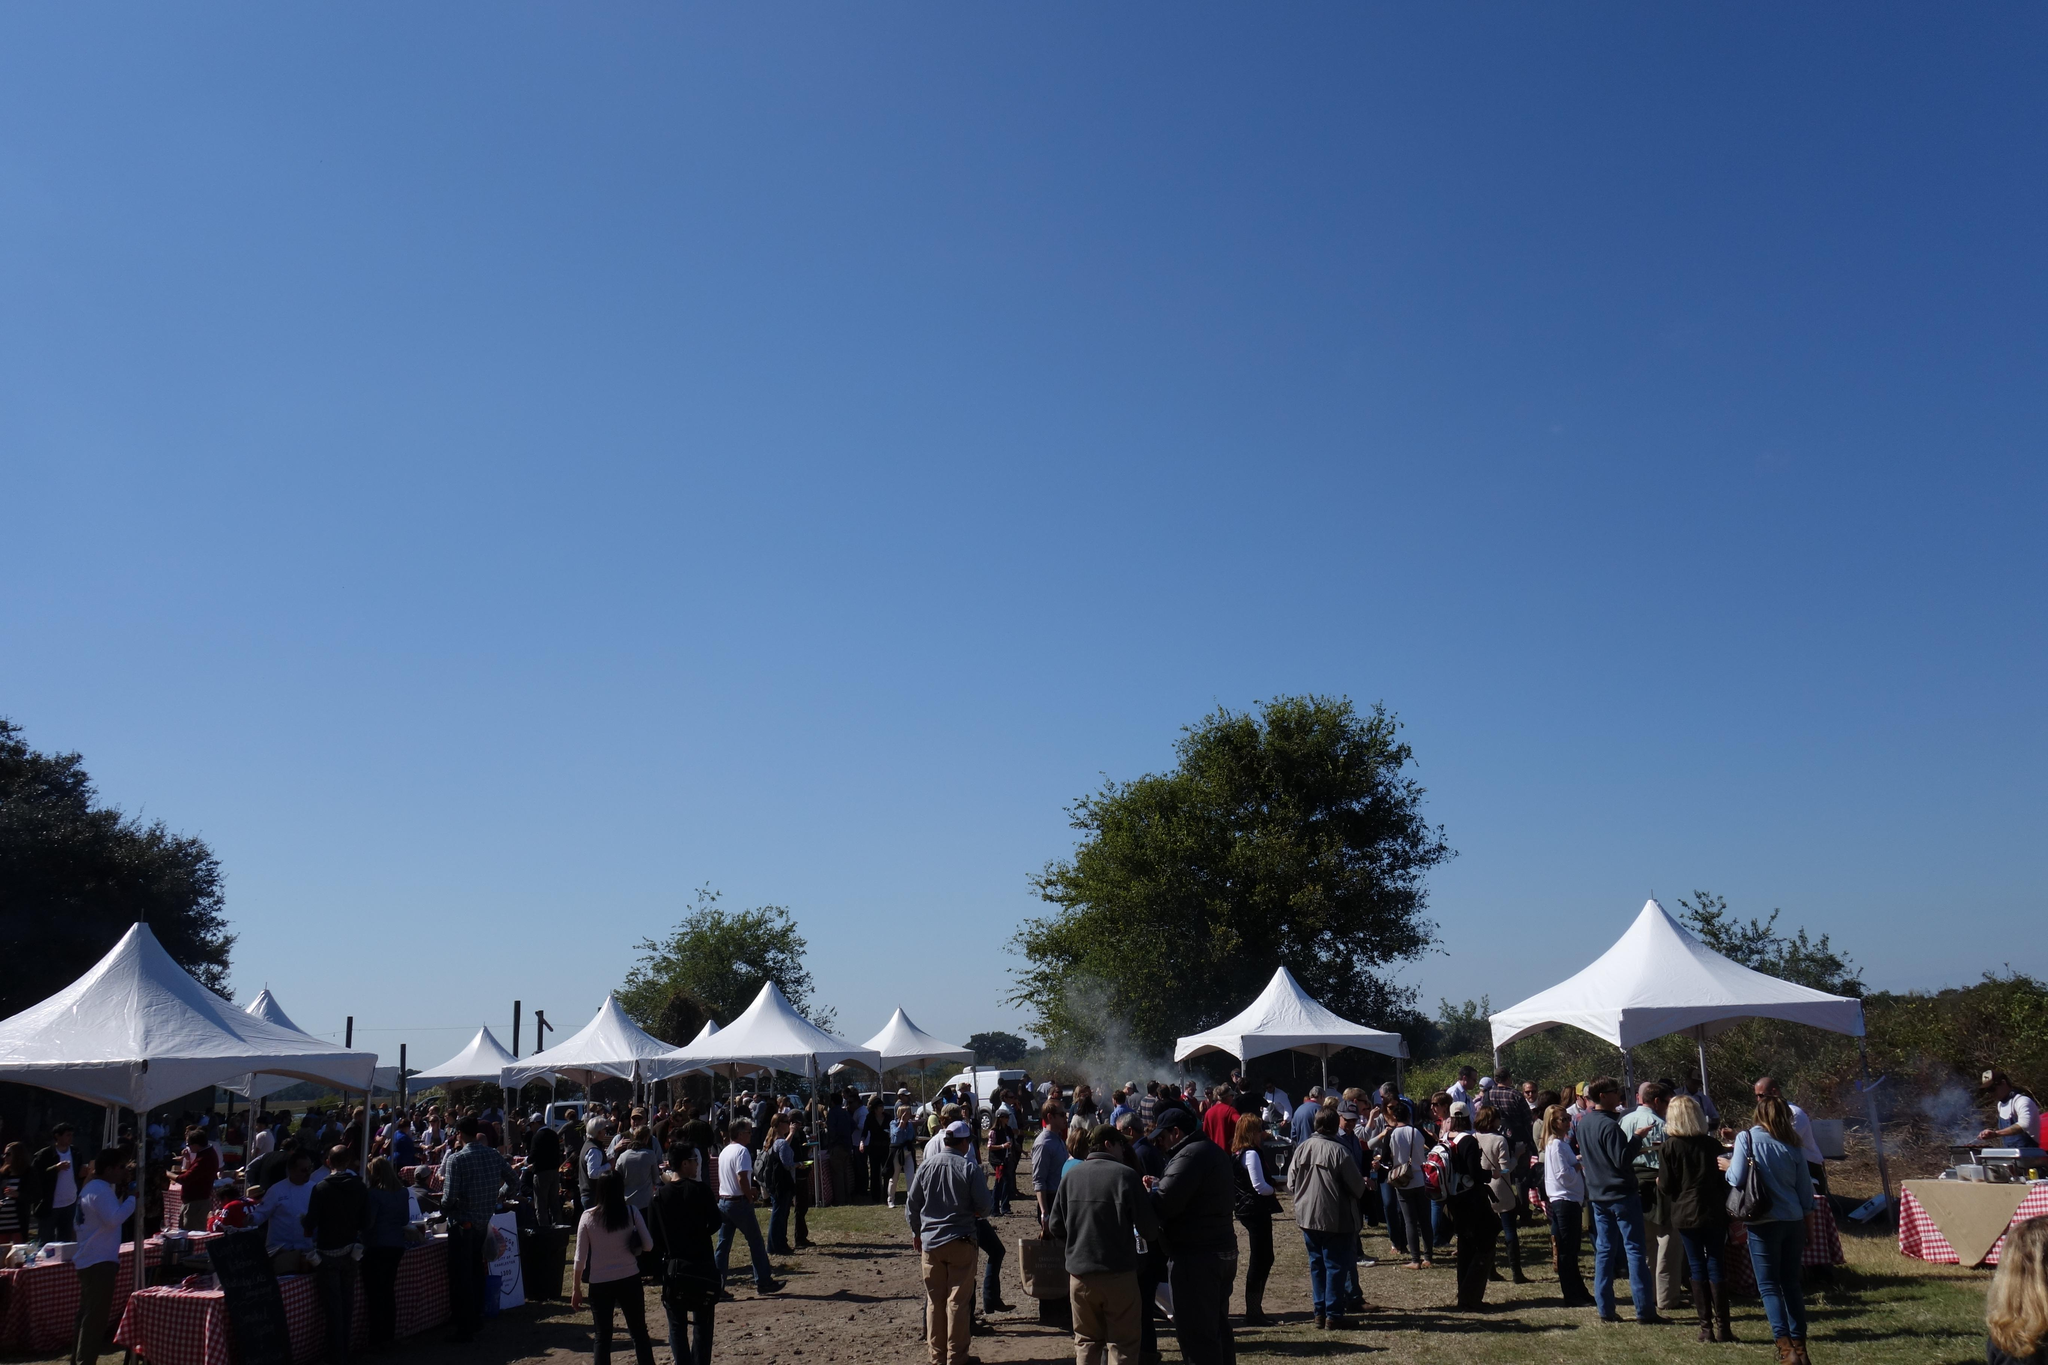What type of natural vegetation can be seen in the image? There are trees in the image. What structures are visible in the image? There are tents in the image. Who or what is present in the image? There are people in the image. What is visible in the background of the image? The sky is visible in the image. What type of wrist accessory is being worn by the trees in the image? There are no wrist accessories present in the image, as the trees are natural vegetation. How does the acoustics of the tents affect the sound quality in the image? There is no information about the acoustics of the tents or any sound quality in the image. 